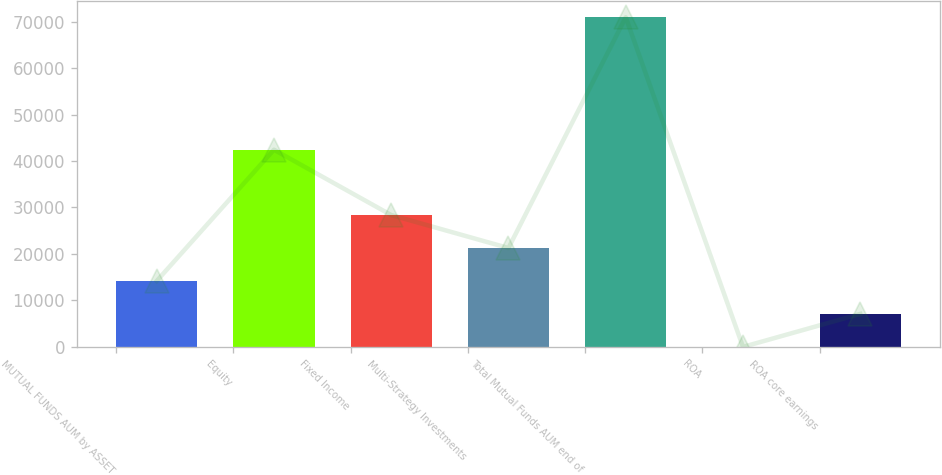<chart> <loc_0><loc_0><loc_500><loc_500><bar_chart><fcel>MUTUAL FUNDS AUM by ASSET<fcel>Equity<fcel>Fixed Income<fcel>Multi-Strategy Investments<fcel>Total Mutual Funds AUM end of<fcel>ROA<fcel>ROA core earnings<nl><fcel>14190.2<fcel>42426<fcel>28372.1<fcel>21281.1<fcel>70918<fcel>8.2<fcel>7099.18<nl></chart> 